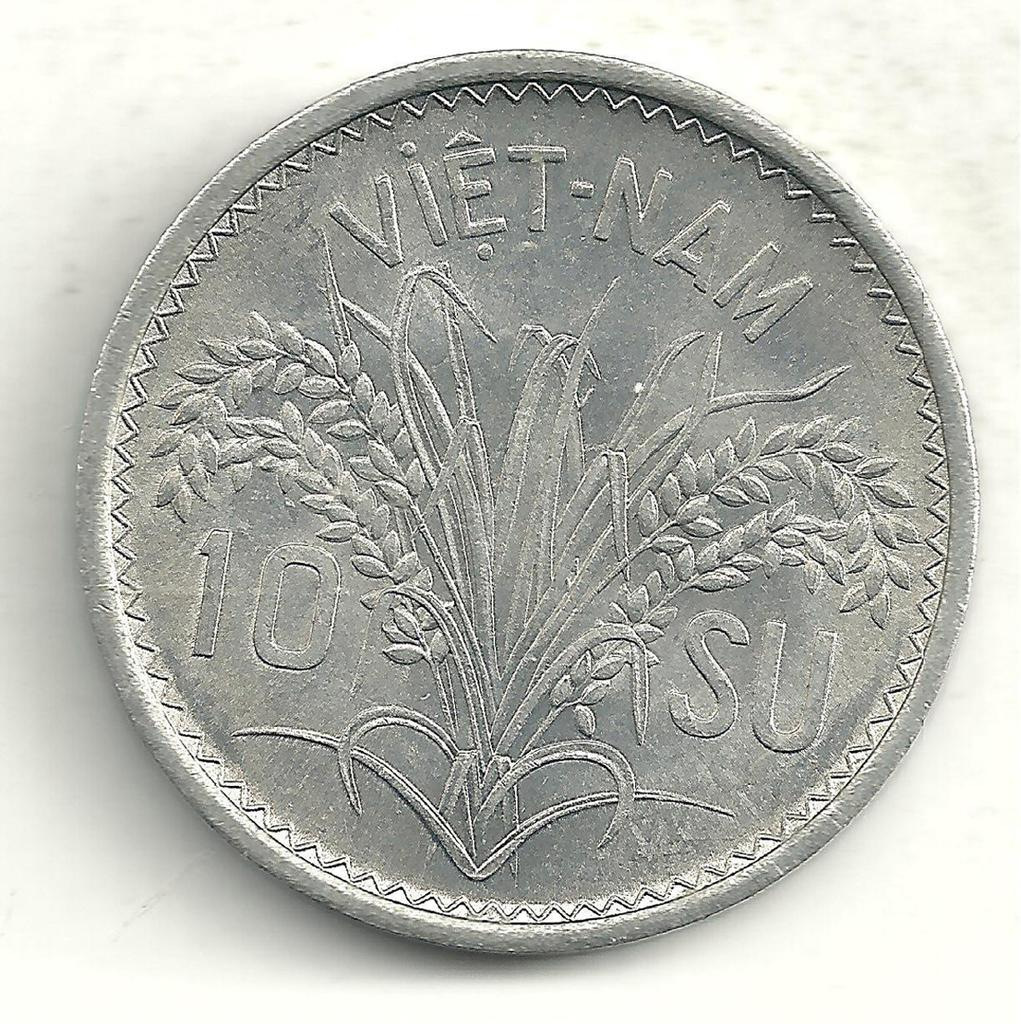Provide a one-sentence caption for the provided image. A silver coin from Vietnam that says 10 SU.. 